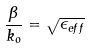Convert formula to latex. <formula><loc_0><loc_0><loc_500><loc_500>\frac { \beta } { k _ { o } } = \sqrt { \epsilon _ { e f f } }</formula> 